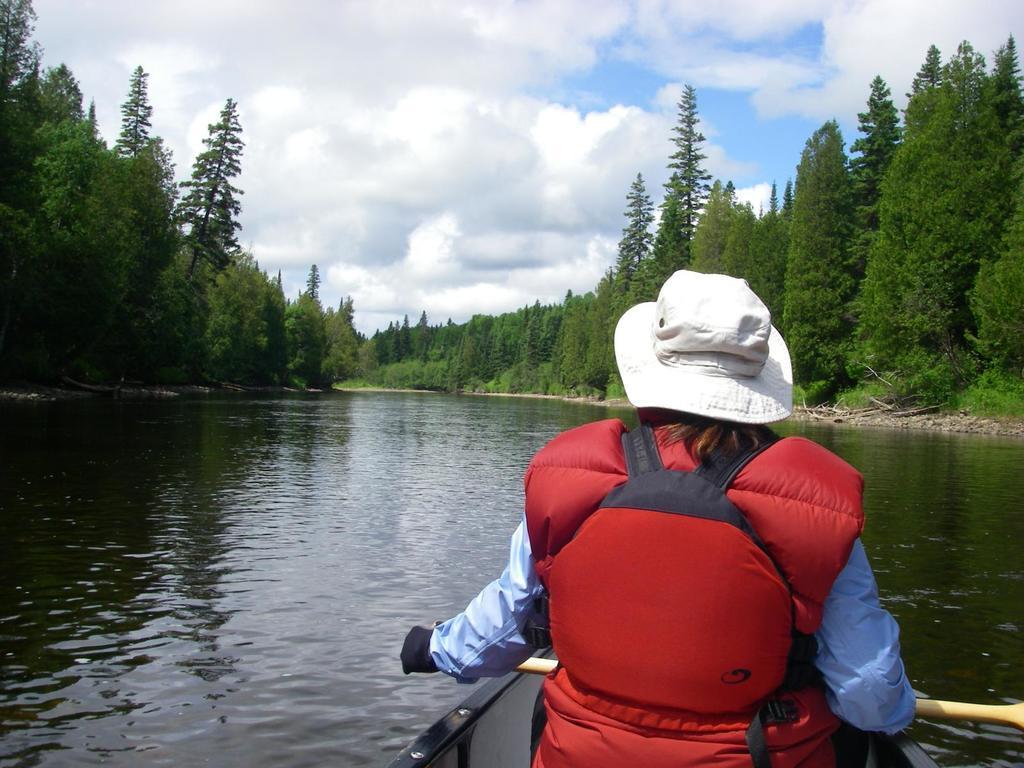Describe this image in one or two sentences. In the foreground of this image, there is a person wearing life jacket and a hat is sitting on a boat holding a paddle. In the background, there is water, trees, sky and the cloud. 